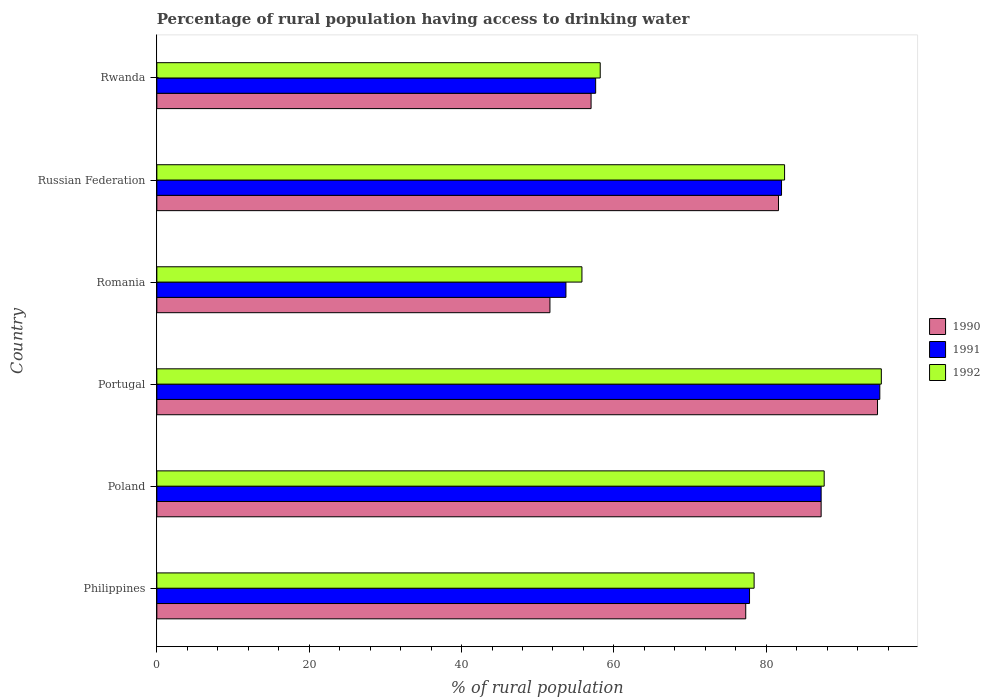How many groups of bars are there?
Provide a succinct answer. 6. Are the number of bars per tick equal to the number of legend labels?
Keep it short and to the point. Yes. How many bars are there on the 4th tick from the top?
Keep it short and to the point. 3. How many bars are there on the 2nd tick from the bottom?
Provide a short and direct response. 3. What is the label of the 2nd group of bars from the top?
Your response must be concise. Russian Federation. What is the percentage of rural population having access to drinking water in 1991 in Portugal?
Your answer should be compact. 94.9. Across all countries, what is the maximum percentage of rural population having access to drinking water in 1990?
Make the answer very short. 94.6. Across all countries, what is the minimum percentage of rural population having access to drinking water in 1992?
Your answer should be very brief. 55.8. In which country was the percentage of rural population having access to drinking water in 1991 maximum?
Provide a short and direct response. Portugal. In which country was the percentage of rural population having access to drinking water in 1992 minimum?
Give a very brief answer. Romania. What is the total percentage of rural population having access to drinking water in 1992 in the graph?
Provide a succinct answer. 457.5. What is the difference between the percentage of rural population having access to drinking water in 1992 in Romania and that in Russian Federation?
Your answer should be very brief. -26.6. What is the difference between the percentage of rural population having access to drinking water in 1992 in Russian Federation and the percentage of rural population having access to drinking water in 1991 in Poland?
Ensure brevity in your answer.  -4.8. What is the average percentage of rural population having access to drinking water in 1991 per country?
Offer a very short reply. 75.53. In how many countries, is the percentage of rural population having access to drinking water in 1991 greater than 44 %?
Keep it short and to the point. 6. What is the ratio of the percentage of rural population having access to drinking water in 1991 in Philippines to that in Romania?
Your answer should be very brief. 1.45. Is the percentage of rural population having access to drinking water in 1990 in Portugal less than that in Rwanda?
Your answer should be compact. No. Is the difference between the percentage of rural population having access to drinking water in 1990 in Romania and Russian Federation greater than the difference between the percentage of rural population having access to drinking water in 1991 in Romania and Russian Federation?
Your answer should be compact. No. What is the difference between the highest and the lowest percentage of rural population having access to drinking water in 1990?
Provide a succinct answer. 43. In how many countries, is the percentage of rural population having access to drinking water in 1991 greater than the average percentage of rural population having access to drinking water in 1991 taken over all countries?
Give a very brief answer. 4. What does the 3rd bar from the top in Poland represents?
Your answer should be very brief. 1990. How many bars are there?
Ensure brevity in your answer.  18. What is the difference between two consecutive major ticks on the X-axis?
Your answer should be compact. 20. Does the graph contain any zero values?
Provide a succinct answer. No. Where does the legend appear in the graph?
Offer a very short reply. Center right. What is the title of the graph?
Give a very brief answer. Percentage of rural population having access to drinking water. What is the label or title of the X-axis?
Offer a terse response. % of rural population. What is the % of rural population of 1990 in Philippines?
Provide a short and direct response. 77.3. What is the % of rural population in 1991 in Philippines?
Provide a succinct answer. 77.8. What is the % of rural population of 1992 in Philippines?
Give a very brief answer. 78.4. What is the % of rural population of 1990 in Poland?
Ensure brevity in your answer.  87.2. What is the % of rural population of 1991 in Poland?
Your answer should be very brief. 87.2. What is the % of rural population of 1992 in Poland?
Your answer should be compact. 87.6. What is the % of rural population in 1990 in Portugal?
Provide a short and direct response. 94.6. What is the % of rural population of 1991 in Portugal?
Give a very brief answer. 94.9. What is the % of rural population in 1992 in Portugal?
Your response must be concise. 95.1. What is the % of rural population in 1990 in Romania?
Keep it short and to the point. 51.6. What is the % of rural population of 1991 in Romania?
Provide a succinct answer. 53.7. What is the % of rural population in 1992 in Romania?
Your answer should be very brief. 55.8. What is the % of rural population in 1990 in Russian Federation?
Give a very brief answer. 81.6. What is the % of rural population in 1992 in Russian Federation?
Your answer should be very brief. 82.4. What is the % of rural population of 1991 in Rwanda?
Your answer should be very brief. 57.6. What is the % of rural population in 1992 in Rwanda?
Provide a short and direct response. 58.2. Across all countries, what is the maximum % of rural population of 1990?
Give a very brief answer. 94.6. Across all countries, what is the maximum % of rural population in 1991?
Your response must be concise. 94.9. Across all countries, what is the maximum % of rural population of 1992?
Provide a short and direct response. 95.1. Across all countries, what is the minimum % of rural population of 1990?
Offer a very short reply. 51.6. Across all countries, what is the minimum % of rural population of 1991?
Ensure brevity in your answer.  53.7. Across all countries, what is the minimum % of rural population in 1992?
Offer a very short reply. 55.8. What is the total % of rural population of 1990 in the graph?
Your response must be concise. 449.3. What is the total % of rural population of 1991 in the graph?
Give a very brief answer. 453.2. What is the total % of rural population of 1992 in the graph?
Offer a terse response. 457.5. What is the difference between the % of rural population in 1991 in Philippines and that in Poland?
Provide a short and direct response. -9.4. What is the difference between the % of rural population in 1990 in Philippines and that in Portugal?
Offer a terse response. -17.3. What is the difference between the % of rural population of 1991 in Philippines and that in Portugal?
Offer a very short reply. -17.1. What is the difference between the % of rural population in 1992 in Philippines and that in Portugal?
Provide a succinct answer. -16.7. What is the difference between the % of rural population in 1990 in Philippines and that in Romania?
Keep it short and to the point. 25.7. What is the difference between the % of rural population in 1991 in Philippines and that in Romania?
Your answer should be very brief. 24.1. What is the difference between the % of rural population in 1992 in Philippines and that in Romania?
Ensure brevity in your answer.  22.6. What is the difference between the % of rural population of 1991 in Philippines and that in Russian Federation?
Give a very brief answer. -4.2. What is the difference between the % of rural population of 1990 in Philippines and that in Rwanda?
Provide a succinct answer. 20.3. What is the difference between the % of rural population in 1991 in Philippines and that in Rwanda?
Provide a succinct answer. 20.2. What is the difference between the % of rural population of 1992 in Philippines and that in Rwanda?
Ensure brevity in your answer.  20.2. What is the difference between the % of rural population in 1992 in Poland and that in Portugal?
Your answer should be very brief. -7.5. What is the difference between the % of rural population of 1990 in Poland and that in Romania?
Give a very brief answer. 35.6. What is the difference between the % of rural population of 1991 in Poland and that in Romania?
Give a very brief answer. 33.5. What is the difference between the % of rural population of 1992 in Poland and that in Romania?
Your answer should be compact. 31.8. What is the difference between the % of rural population of 1991 in Poland and that in Russian Federation?
Keep it short and to the point. 5.2. What is the difference between the % of rural population of 1992 in Poland and that in Russian Federation?
Provide a short and direct response. 5.2. What is the difference between the % of rural population in 1990 in Poland and that in Rwanda?
Offer a very short reply. 30.2. What is the difference between the % of rural population in 1991 in Poland and that in Rwanda?
Provide a short and direct response. 29.6. What is the difference between the % of rural population in 1992 in Poland and that in Rwanda?
Your answer should be very brief. 29.4. What is the difference between the % of rural population in 1990 in Portugal and that in Romania?
Provide a succinct answer. 43. What is the difference between the % of rural population in 1991 in Portugal and that in Romania?
Offer a very short reply. 41.2. What is the difference between the % of rural population in 1992 in Portugal and that in Romania?
Your answer should be compact. 39.3. What is the difference between the % of rural population in 1990 in Portugal and that in Russian Federation?
Give a very brief answer. 13. What is the difference between the % of rural population of 1992 in Portugal and that in Russian Federation?
Your answer should be compact. 12.7. What is the difference between the % of rural population in 1990 in Portugal and that in Rwanda?
Offer a terse response. 37.6. What is the difference between the % of rural population of 1991 in Portugal and that in Rwanda?
Offer a terse response. 37.3. What is the difference between the % of rural population of 1992 in Portugal and that in Rwanda?
Your response must be concise. 36.9. What is the difference between the % of rural population in 1990 in Romania and that in Russian Federation?
Ensure brevity in your answer.  -30. What is the difference between the % of rural population of 1991 in Romania and that in Russian Federation?
Your answer should be very brief. -28.3. What is the difference between the % of rural population of 1992 in Romania and that in Russian Federation?
Provide a short and direct response. -26.6. What is the difference between the % of rural population of 1991 in Romania and that in Rwanda?
Offer a very short reply. -3.9. What is the difference between the % of rural population of 1990 in Russian Federation and that in Rwanda?
Offer a terse response. 24.6. What is the difference between the % of rural population in 1991 in Russian Federation and that in Rwanda?
Provide a short and direct response. 24.4. What is the difference between the % of rural population of 1992 in Russian Federation and that in Rwanda?
Ensure brevity in your answer.  24.2. What is the difference between the % of rural population of 1990 in Philippines and the % of rural population of 1991 in Poland?
Provide a succinct answer. -9.9. What is the difference between the % of rural population in 1990 in Philippines and the % of rural population in 1992 in Poland?
Your response must be concise. -10.3. What is the difference between the % of rural population of 1991 in Philippines and the % of rural population of 1992 in Poland?
Offer a terse response. -9.8. What is the difference between the % of rural population of 1990 in Philippines and the % of rural population of 1991 in Portugal?
Make the answer very short. -17.6. What is the difference between the % of rural population in 1990 in Philippines and the % of rural population in 1992 in Portugal?
Give a very brief answer. -17.8. What is the difference between the % of rural population in 1991 in Philippines and the % of rural population in 1992 in Portugal?
Your response must be concise. -17.3. What is the difference between the % of rural population in 1990 in Philippines and the % of rural population in 1991 in Romania?
Your answer should be very brief. 23.6. What is the difference between the % of rural population in 1991 in Philippines and the % of rural population in 1992 in Romania?
Your answer should be very brief. 22. What is the difference between the % of rural population of 1990 in Philippines and the % of rural population of 1991 in Russian Federation?
Your answer should be compact. -4.7. What is the difference between the % of rural population in 1990 in Philippines and the % of rural population in 1992 in Russian Federation?
Your answer should be compact. -5.1. What is the difference between the % of rural population of 1991 in Philippines and the % of rural population of 1992 in Russian Federation?
Offer a terse response. -4.6. What is the difference between the % of rural population of 1990 in Philippines and the % of rural population of 1991 in Rwanda?
Your answer should be very brief. 19.7. What is the difference between the % of rural population of 1991 in Philippines and the % of rural population of 1992 in Rwanda?
Your answer should be very brief. 19.6. What is the difference between the % of rural population in 1991 in Poland and the % of rural population in 1992 in Portugal?
Your answer should be very brief. -7.9. What is the difference between the % of rural population in 1990 in Poland and the % of rural population in 1991 in Romania?
Your response must be concise. 33.5. What is the difference between the % of rural population in 1990 in Poland and the % of rural population in 1992 in Romania?
Your response must be concise. 31.4. What is the difference between the % of rural population of 1991 in Poland and the % of rural population of 1992 in Romania?
Give a very brief answer. 31.4. What is the difference between the % of rural population in 1990 in Poland and the % of rural population in 1991 in Russian Federation?
Provide a short and direct response. 5.2. What is the difference between the % of rural population in 1991 in Poland and the % of rural population in 1992 in Russian Federation?
Offer a terse response. 4.8. What is the difference between the % of rural population in 1990 in Poland and the % of rural population in 1991 in Rwanda?
Keep it short and to the point. 29.6. What is the difference between the % of rural population in 1990 in Portugal and the % of rural population in 1991 in Romania?
Your answer should be very brief. 40.9. What is the difference between the % of rural population in 1990 in Portugal and the % of rural population in 1992 in Romania?
Offer a very short reply. 38.8. What is the difference between the % of rural population of 1991 in Portugal and the % of rural population of 1992 in Romania?
Your answer should be compact. 39.1. What is the difference between the % of rural population of 1990 in Portugal and the % of rural population of 1992 in Russian Federation?
Your answer should be compact. 12.2. What is the difference between the % of rural population in 1991 in Portugal and the % of rural population in 1992 in Russian Federation?
Offer a very short reply. 12.5. What is the difference between the % of rural population of 1990 in Portugal and the % of rural population of 1991 in Rwanda?
Ensure brevity in your answer.  37. What is the difference between the % of rural population of 1990 in Portugal and the % of rural population of 1992 in Rwanda?
Offer a terse response. 36.4. What is the difference between the % of rural population in 1991 in Portugal and the % of rural population in 1992 in Rwanda?
Your answer should be compact. 36.7. What is the difference between the % of rural population of 1990 in Romania and the % of rural population of 1991 in Russian Federation?
Provide a succinct answer. -30.4. What is the difference between the % of rural population of 1990 in Romania and the % of rural population of 1992 in Russian Federation?
Keep it short and to the point. -30.8. What is the difference between the % of rural population in 1991 in Romania and the % of rural population in 1992 in Russian Federation?
Offer a terse response. -28.7. What is the difference between the % of rural population of 1990 in Romania and the % of rural population of 1992 in Rwanda?
Your answer should be compact. -6.6. What is the difference between the % of rural population in 1990 in Russian Federation and the % of rural population in 1992 in Rwanda?
Keep it short and to the point. 23.4. What is the difference between the % of rural population of 1991 in Russian Federation and the % of rural population of 1992 in Rwanda?
Ensure brevity in your answer.  23.8. What is the average % of rural population in 1990 per country?
Your answer should be compact. 74.88. What is the average % of rural population of 1991 per country?
Make the answer very short. 75.53. What is the average % of rural population of 1992 per country?
Provide a short and direct response. 76.25. What is the difference between the % of rural population of 1990 and % of rural population of 1991 in Philippines?
Offer a very short reply. -0.5. What is the difference between the % of rural population of 1991 and % of rural population of 1992 in Philippines?
Keep it short and to the point. -0.6. What is the difference between the % of rural population of 1991 and % of rural population of 1992 in Poland?
Keep it short and to the point. -0.4. What is the difference between the % of rural population of 1990 and % of rural population of 1992 in Portugal?
Ensure brevity in your answer.  -0.5. What is the difference between the % of rural population in 1991 and % of rural population in 1992 in Portugal?
Make the answer very short. -0.2. What is the difference between the % of rural population in 1990 and % of rural population in 1991 in Romania?
Offer a very short reply. -2.1. What is the difference between the % of rural population in 1991 and % of rural population in 1992 in Romania?
Give a very brief answer. -2.1. What is the difference between the % of rural population of 1990 and % of rural population of 1992 in Russian Federation?
Your answer should be very brief. -0.8. What is the difference between the % of rural population of 1990 and % of rural population of 1991 in Rwanda?
Ensure brevity in your answer.  -0.6. What is the difference between the % of rural population of 1991 and % of rural population of 1992 in Rwanda?
Your answer should be very brief. -0.6. What is the ratio of the % of rural population of 1990 in Philippines to that in Poland?
Give a very brief answer. 0.89. What is the ratio of the % of rural population in 1991 in Philippines to that in Poland?
Keep it short and to the point. 0.89. What is the ratio of the % of rural population in 1992 in Philippines to that in Poland?
Give a very brief answer. 0.9. What is the ratio of the % of rural population in 1990 in Philippines to that in Portugal?
Ensure brevity in your answer.  0.82. What is the ratio of the % of rural population of 1991 in Philippines to that in Portugal?
Your answer should be very brief. 0.82. What is the ratio of the % of rural population of 1992 in Philippines to that in Portugal?
Your answer should be compact. 0.82. What is the ratio of the % of rural population of 1990 in Philippines to that in Romania?
Give a very brief answer. 1.5. What is the ratio of the % of rural population in 1991 in Philippines to that in Romania?
Offer a very short reply. 1.45. What is the ratio of the % of rural population in 1992 in Philippines to that in Romania?
Provide a succinct answer. 1.41. What is the ratio of the % of rural population in 1990 in Philippines to that in Russian Federation?
Offer a very short reply. 0.95. What is the ratio of the % of rural population of 1991 in Philippines to that in Russian Federation?
Keep it short and to the point. 0.95. What is the ratio of the % of rural population in 1992 in Philippines to that in Russian Federation?
Ensure brevity in your answer.  0.95. What is the ratio of the % of rural population of 1990 in Philippines to that in Rwanda?
Offer a very short reply. 1.36. What is the ratio of the % of rural population of 1991 in Philippines to that in Rwanda?
Provide a short and direct response. 1.35. What is the ratio of the % of rural population in 1992 in Philippines to that in Rwanda?
Your response must be concise. 1.35. What is the ratio of the % of rural population of 1990 in Poland to that in Portugal?
Give a very brief answer. 0.92. What is the ratio of the % of rural population of 1991 in Poland to that in Portugal?
Your response must be concise. 0.92. What is the ratio of the % of rural population of 1992 in Poland to that in Portugal?
Keep it short and to the point. 0.92. What is the ratio of the % of rural population of 1990 in Poland to that in Romania?
Provide a short and direct response. 1.69. What is the ratio of the % of rural population of 1991 in Poland to that in Romania?
Offer a terse response. 1.62. What is the ratio of the % of rural population in 1992 in Poland to that in Romania?
Keep it short and to the point. 1.57. What is the ratio of the % of rural population in 1990 in Poland to that in Russian Federation?
Ensure brevity in your answer.  1.07. What is the ratio of the % of rural population in 1991 in Poland to that in Russian Federation?
Your answer should be very brief. 1.06. What is the ratio of the % of rural population of 1992 in Poland to that in Russian Federation?
Make the answer very short. 1.06. What is the ratio of the % of rural population of 1990 in Poland to that in Rwanda?
Your answer should be compact. 1.53. What is the ratio of the % of rural population of 1991 in Poland to that in Rwanda?
Give a very brief answer. 1.51. What is the ratio of the % of rural population of 1992 in Poland to that in Rwanda?
Provide a succinct answer. 1.51. What is the ratio of the % of rural population of 1990 in Portugal to that in Romania?
Your answer should be very brief. 1.83. What is the ratio of the % of rural population in 1991 in Portugal to that in Romania?
Ensure brevity in your answer.  1.77. What is the ratio of the % of rural population in 1992 in Portugal to that in Romania?
Keep it short and to the point. 1.7. What is the ratio of the % of rural population of 1990 in Portugal to that in Russian Federation?
Give a very brief answer. 1.16. What is the ratio of the % of rural population of 1991 in Portugal to that in Russian Federation?
Your answer should be very brief. 1.16. What is the ratio of the % of rural population of 1992 in Portugal to that in Russian Federation?
Ensure brevity in your answer.  1.15. What is the ratio of the % of rural population of 1990 in Portugal to that in Rwanda?
Make the answer very short. 1.66. What is the ratio of the % of rural population in 1991 in Portugal to that in Rwanda?
Your answer should be compact. 1.65. What is the ratio of the % of rural population of 1992 in Portugal to that in Rwanda?
Make the answer very short. 1.63. What is the ratio of the % of rural population in 1990 in Romania to that in Russian Federation?
Provide a succinct answer. 0.63. What is the ratio of the % of rural population in 1991 in Romania to that in Russian Federation?
Offer a very short reply. 0.65. What is the ratio of the % of rural population in 1992 in Romania to that in Russian Federation?
Make the answer very short. 0.68. What is the ratio of the % of rural population of 1990 in Romania to that in Rwanda?
Offer a very short reply. 0.91. What is the ratio of the % of rural population of 1991 in Romania to that in Rwanda?
Make the answer very short. 0.93. What is the ratio of the % of rural population in 1992 in Romania to that in Rwanda?
Your answer should be compact. 0.96. What is the ratio of the % of rural population in 1990 in Russian Federation to that in Rwanda?
Give a very brief answer. 1.43. What is the ratio of the % of rural population of 1991 in Russian Federation to that in Rwanda?
Your answer should be compact. 1.42. What is the ratio of the % of rural population of 1992 in Russian Federation to that in Rwanda?
Provide a short and direct response. 1.42. What is the difference between the highest and the lowest % of rural population of 1990?
Give a very brief answer. 43. What is the difference between the highest and the lowest % of rural population of 1991?
Offer a terse response. 41.2. What is the difference between the highest and the lowest % of rural population of 1992?
Ensure brevity in your answer.  39.3. 